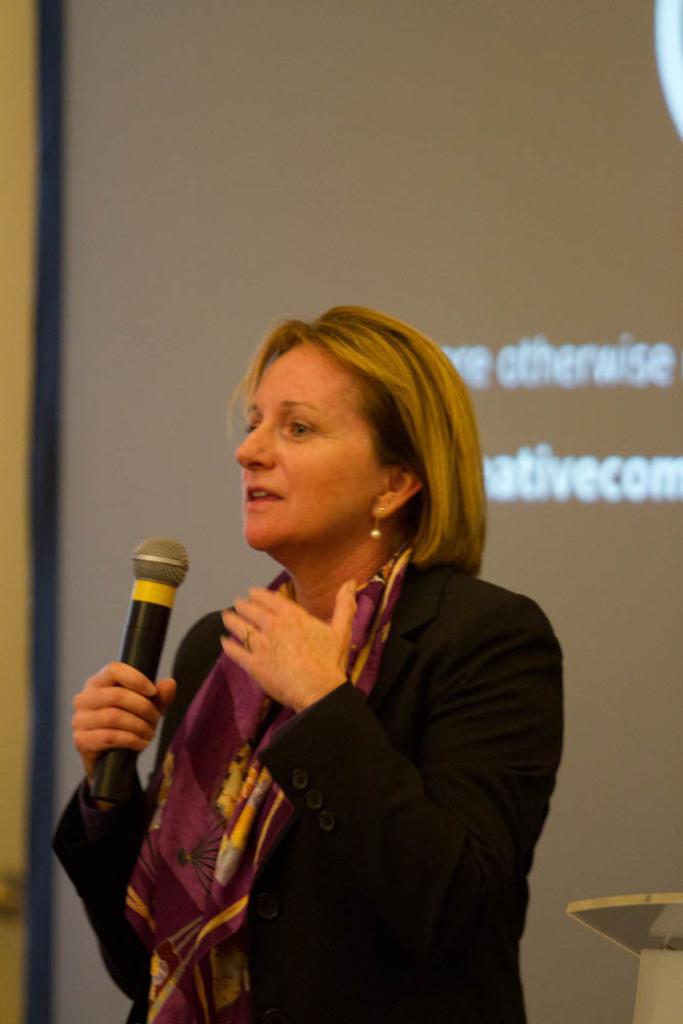Describe this image in one or two sentences. This image consist of a woman wearing black coat. In the background, there is a screen on the wall. 